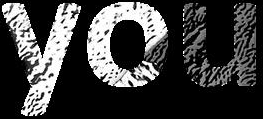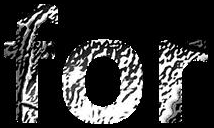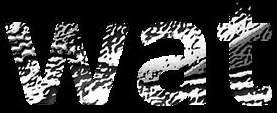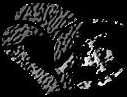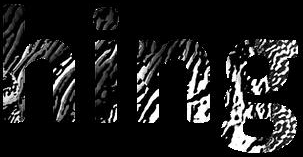Read the text content from these images in order, separated by a semicolon. you; for; wat; #; hing 